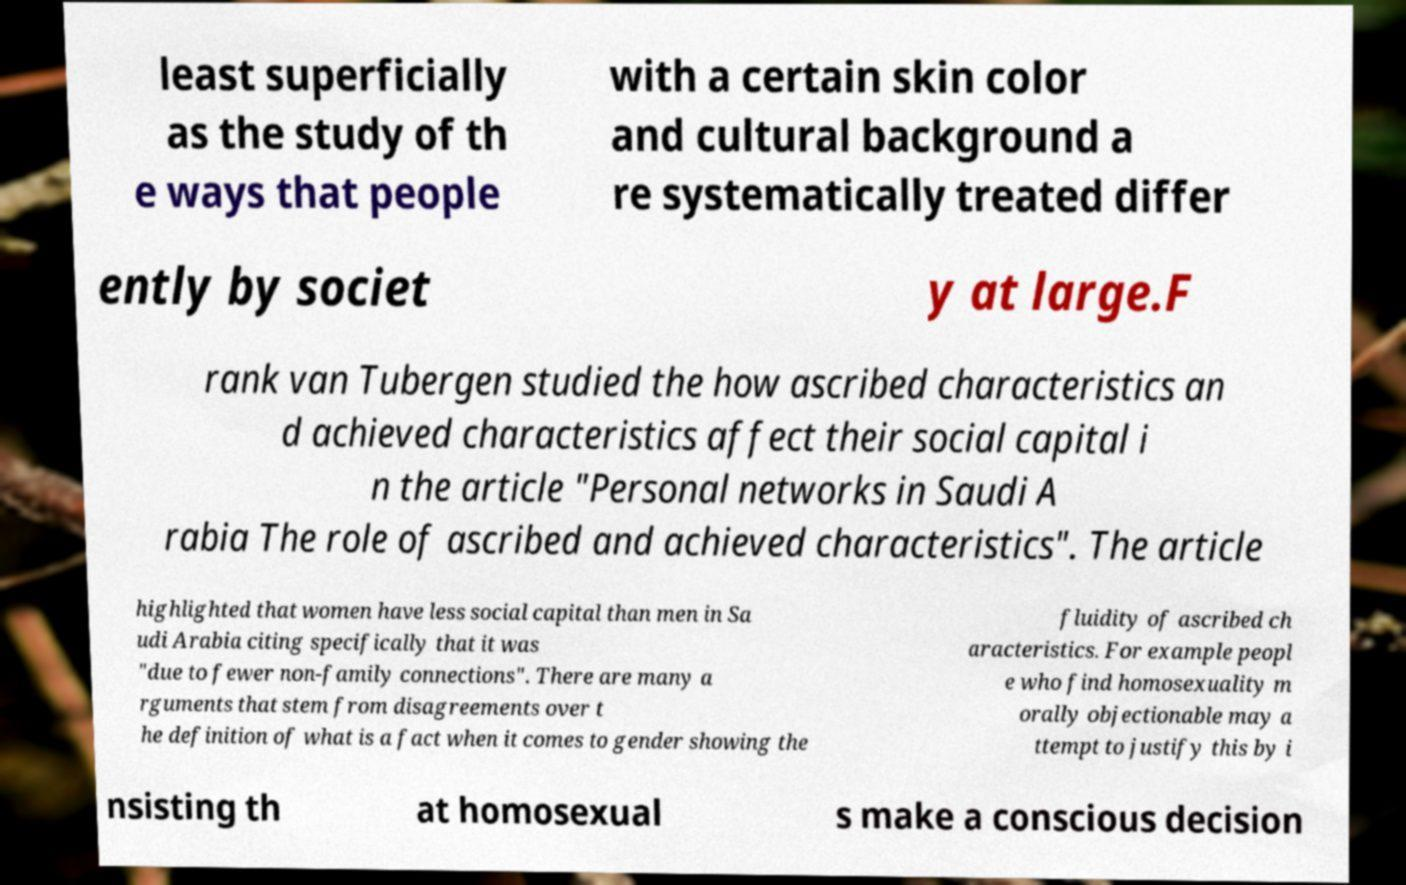What messages or text are displayed in this image? I need them in a readable, typed format. least superficially as the study of th e ways that people with a certain skin color and cultural background a re systematically treated differ ently by societ y at large.F rank van Tubergen studied the how ascribed characteristics an d achieved characteristics affect their social capital i n the article "Personal networks in Saudi A rabia The role of ascribed and achieved characteristics". The article highlighted that women have less social capital than men in Sa udi Arabia citing specifically that it was "due to fewer non-family connections". There are many a rguments that stem from disagreements over t he definition of what is a fact when it comes to gender showing the fluidity of ascribed ch aracteristics. For example peopl e who find homosexuality m orally objectionable may a ttempt to justify this by i nsisting th at homosexual s make a conscious decision 